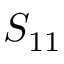<formula> <loc_0><loc_0><loc_500><loc_500>S _ { 1 1 }</formula> 